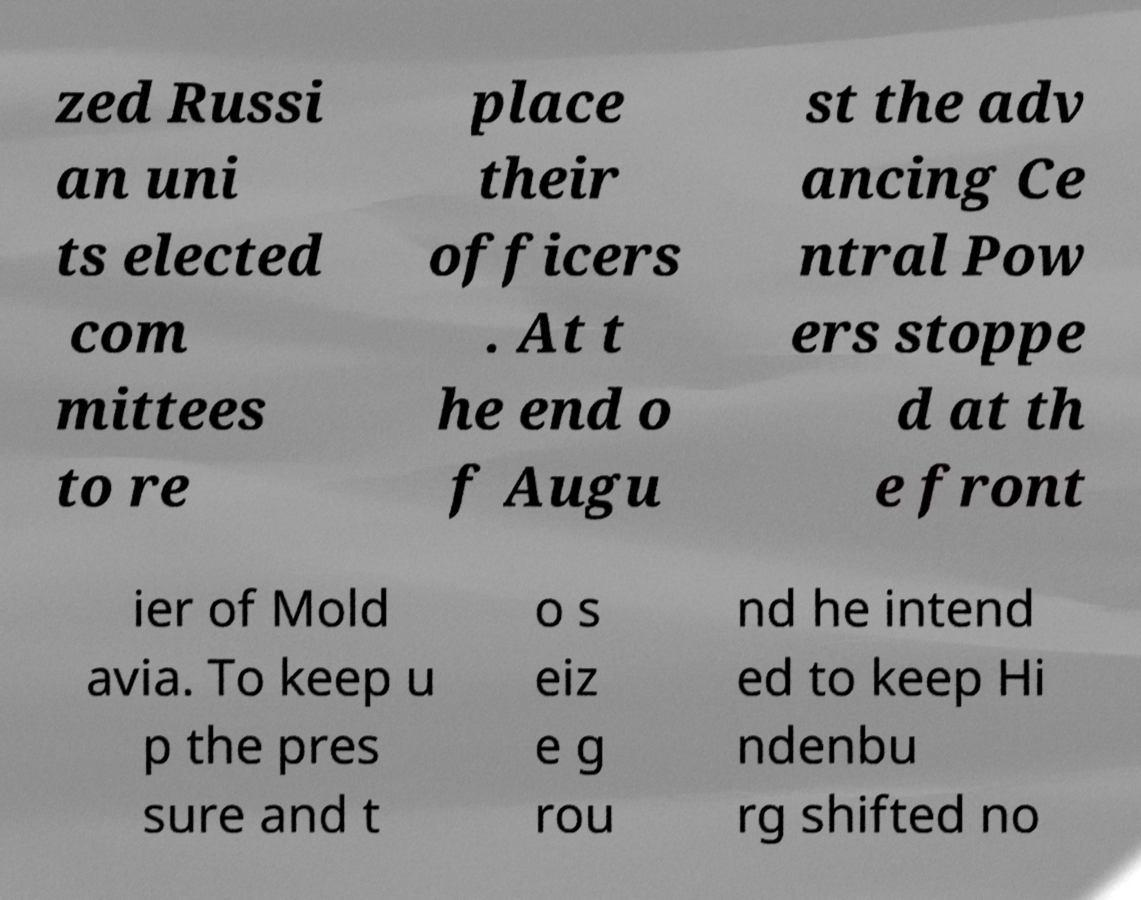I need the written content from this picture converted into text. Can you do that? zed Russi an uni ts elected com mittees to re place their officers . At t he end o f Augu st the adv ancing Ce ntral Pow ers stoppe d at th e front ier of Mold avia. To keep u p the pres sure and t o s eiz e g rou nd he intend ed to keep Hi ndenbu rg shifted no 